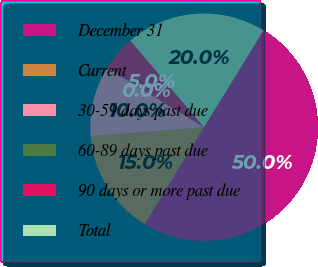Convert chart to OTSL. <chart><loc_0><loc_0><loc_500><loc_500><pie_chart><fcel>December 31<fcel>Current<fcel>30-59 days past due<fcel>60-89 days past due<fcel>90 days or more past due<fcel>Total<nl><fcel>49.96%<fcel>15.0%<fcel>10.01%<fcel>0.02%<fcel>5.02%<fcel>20.0%<nl></chart> 